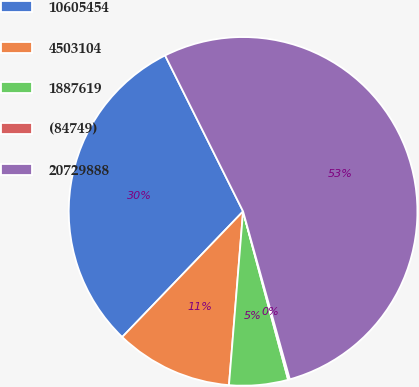Convert chart to OTSL. <chart><loc_0><loc_0><loc_500><loc_500><pie_chart><fcel>10605454<fcel>4503104<fcel>1887619<fcel>(84749)<fcel>20729888<nl><fcel>30.43%<fcel>10.9%<fcel>5.45%<fcel>0.16%<fcel>53.06%<nl></chart> 